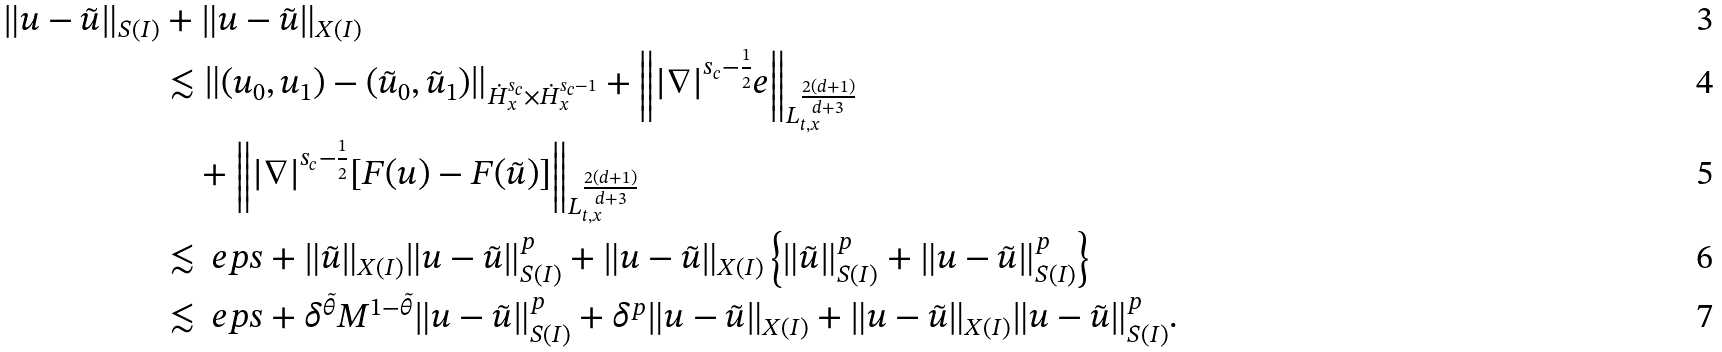Convert formula to latex. <formula><loc_0><loc_0><loc_500><loc_500>\| u - \tilde { u } \| _ { S ( I ) } & + \| u - \tilde { u } \| _ { X ( I ) } \\ & \lesssim \left \| ( u _ { 0 } , u _ { 1 } ) - ( \tilde { u } _ { 0 } , \tilde { u } _ { 1 } ) \right \| _ { \dot { H } _ { x } ^ { s _ { c } } \times \dot { H } _ { x } ^ { s _ { c } - 1 } } + \left \| | \nabla | ^ { s _ { c } - \frac { 1 } { 2 } } e \right \| _ { L _ { t , x } ^ { \frac { 2 ( d + 1 ) } { d + 3 } } } \\ & \quad + \left \| | \nabla | ^ { s _ { c } - \frac { 1 } { 2 } } [ F ( u ) - F ( \tilde { u } ) ] \right \| _ { L _ { t , x } ^ { \frac { 2 ( d + 1 ) } { d + 3 } } } \\ & \lesssim \ e p s + \| \tilde { u } \| _ { X ( I ) } \| u - \tilde { u } \| _ { S ( I ) } ^ { p } + \| u - \tilde { u } \| _ { X ( I ) } \left \{ \| \tilde { u } \| _ { S ( I ) } ^ { p } + \| u - \tilde { u } \| _ { S ( I ) } ^ { p } \right \} \\ & \lesssim \ e p s + \delta ^ { \tilde { \theta } } M ^ { 1 - \tilde { \theta } } \| u - \tilde { u } \| _ { S ( I ) } ^ { p } + \delta ^ { p } \| u - \tilde { u } \| _ { X ( I ) } + \| u - \tilde { u } \| _ { X ( I ) } \| u - \tilde { u } \| _ { S ( I ) } ^ { p } .</formula> 